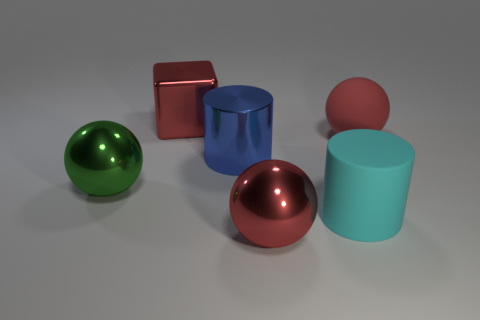What is the shape of the big metallic thing left of the red object that is to the left of the red metallic ball?
Your answer should be compact. Sphere. Is the number of cylinders that are in front of the big cyan rubber object greater than the number of yellow rubber spheres?
Offer a terse response. No. There is a red metallic object that is in front of the green shiny sphere; does it have the same shape as the cyan matte object?
Provide a short and direct response. No. Is there a red thing of the same shape as the big cyan thing?
Your response must be concise. No. How many objects are either red shiny things in front of the rubber cylinder or big metal cubes?
Keep it short and to the point. 2. Is the number of objects greater than the number of big red rubber balls?
Your answer should be compact. Yes. Are there any gray objects that have the same size as the green sphere?
Give a very brief answer. No. What number of things are red spheres that are in front of the large blue shiny thing or large objects that are in front of the big red shiny block?
Ensure brevity in your answer.  5. There is a large sphere that is in front of the big rubber thing that is on the left side of the big matte ball; what is its color?
Your answer should be compact. Red. What color is the large cylinder that is the same material as the big red cube?
Keep it short and to the point. Blue. 